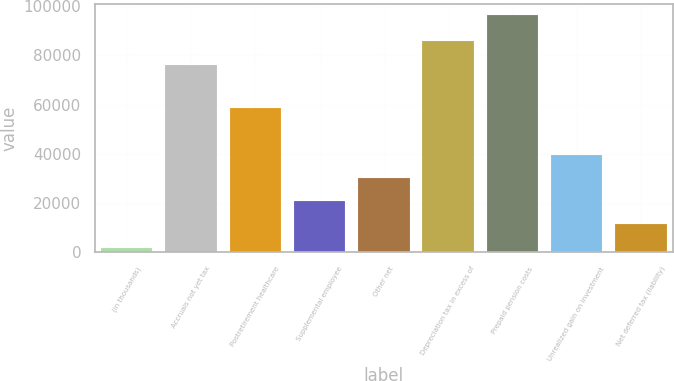Convert chart. <chart><loc_0><loc_0><loc_500><loc_500><bar_chart><fcel>(in thousands)<fcel>Accruals not yet tax<fcel>Postretirement healthcare<fcel>Supplemental employee<fcel>Other net<fcel>Depreciation tax in excess of<fcel>Prepaid pension costs<fcel>Unrealized gain on investment<fcel>Net deferred tax (liability)<nl><fcel>2004<fcel>76192<fcel>58455<fcel>20835.8<fcel>30251.7<fcel>85607.9<fcel>96163<fcel>39667.6<fcel>11419.9<nl></chart> 